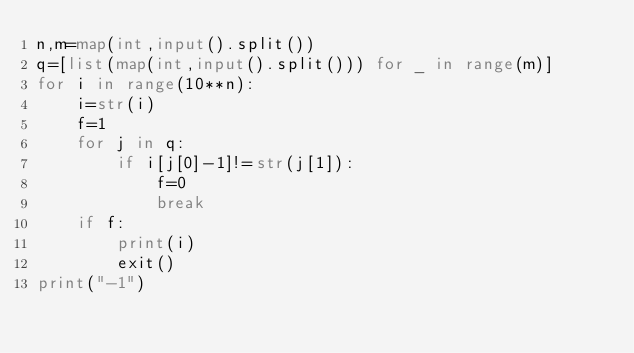<code> <loc_0><loc_0><loc_500><loc_500><_Python_>n,m=map(int,input().split())
q=[list(map(int,input().split())) for _ in range(m)]
for i in range(10**n):
    i=str(i)
    f=1
    for j in q:
        if i[j[0]-1]!=str(j[1]):
            f=0
            break
    if f:
        print(i)
        exit()
print("-1")</code> 